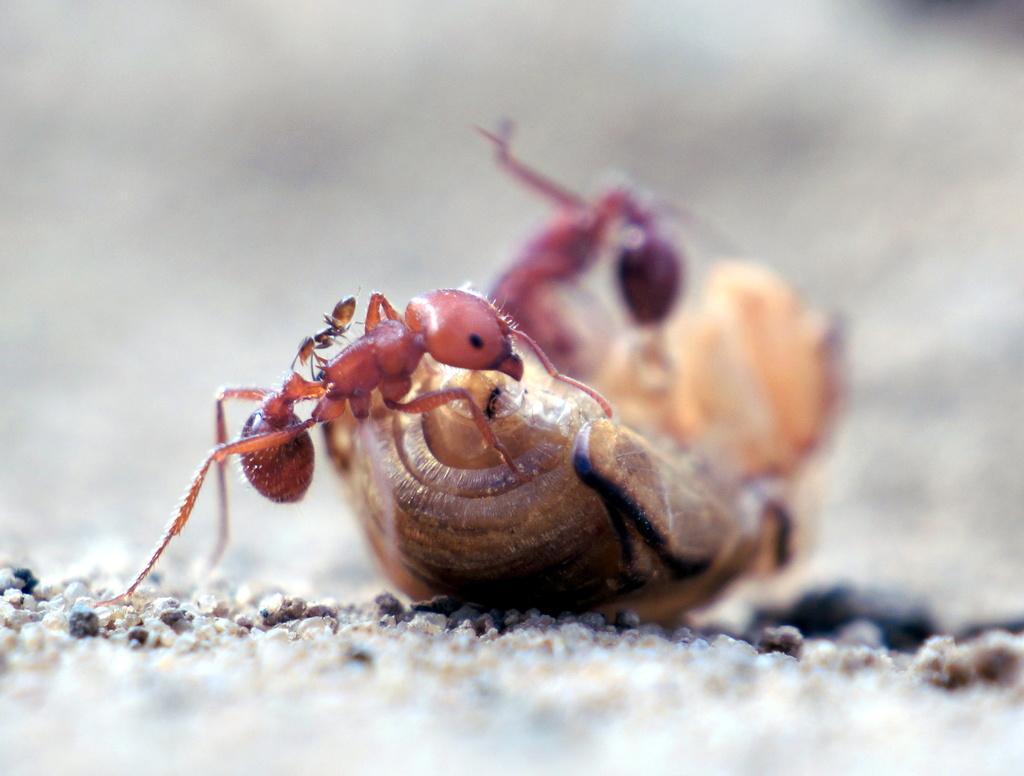Can you describe this image briefly? The picture consists of ants and an insect on the sand. At the top and at the bottom it is blurred. 